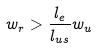Convert formula to latex. <formula><loc_0><loc_0><loc_500><loc_500>w _ { r } > \frac { l _ { e } } { l _ { u s } } w _ { u }</formula> 